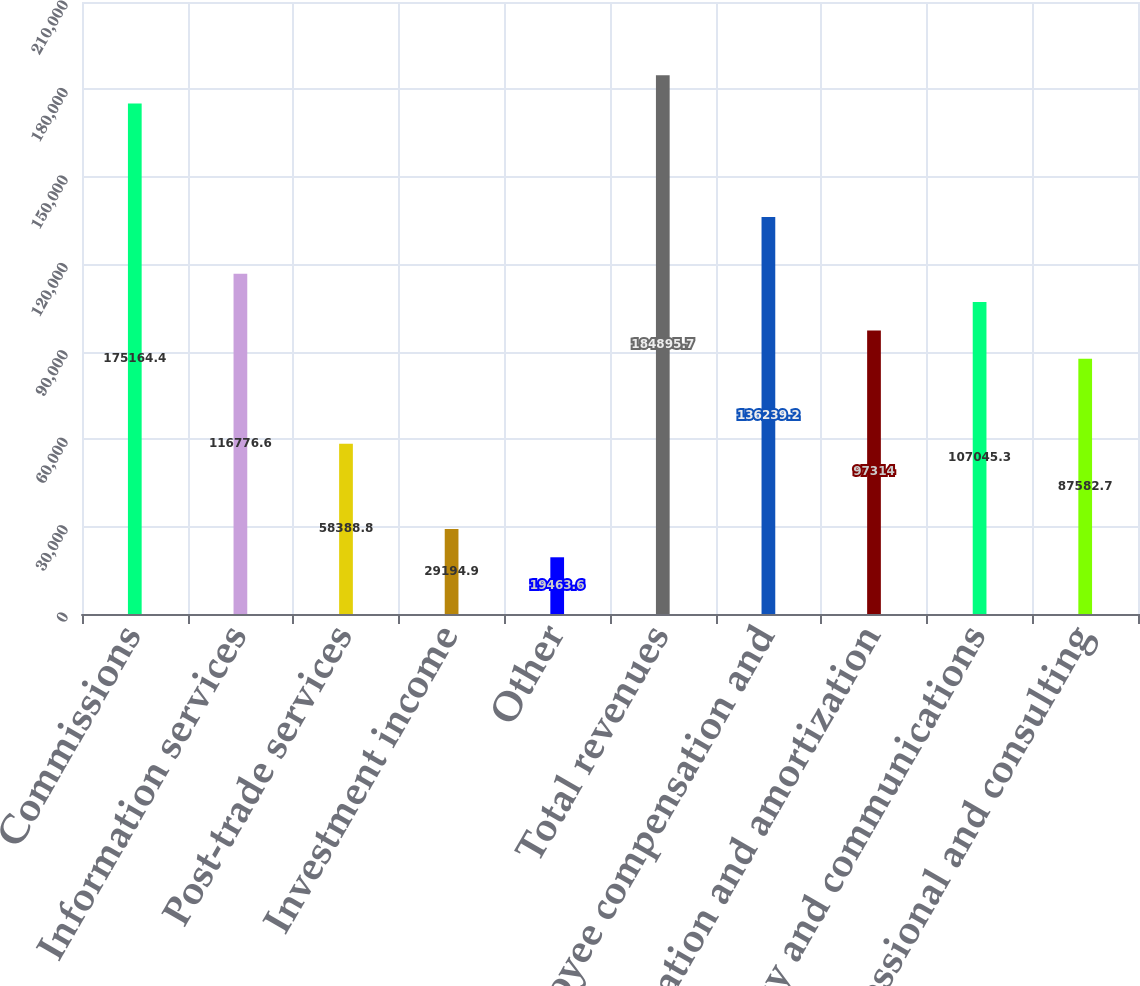Convert chart. <chart><loc_0><loc_0><loc_500><loc_500><bar_chart><fcel>Commissions<fcel>Information services<fcel>Post-trade services<fcel>Investment income<fcel>Other<fcel>Total revenues<fcel>Employee compensation and<fcel>Depreciation and amortization<fcel>Technology and communications<fcel>Professional and consulting<nl><fcel>175164<fcel>116777<fcel>58388.8<fcel>29194.9<fcel>19463.6<fcel>184896<fcel>136239<fcel>97314<fcel>107045<fcel>87582.7<nl></chart> 